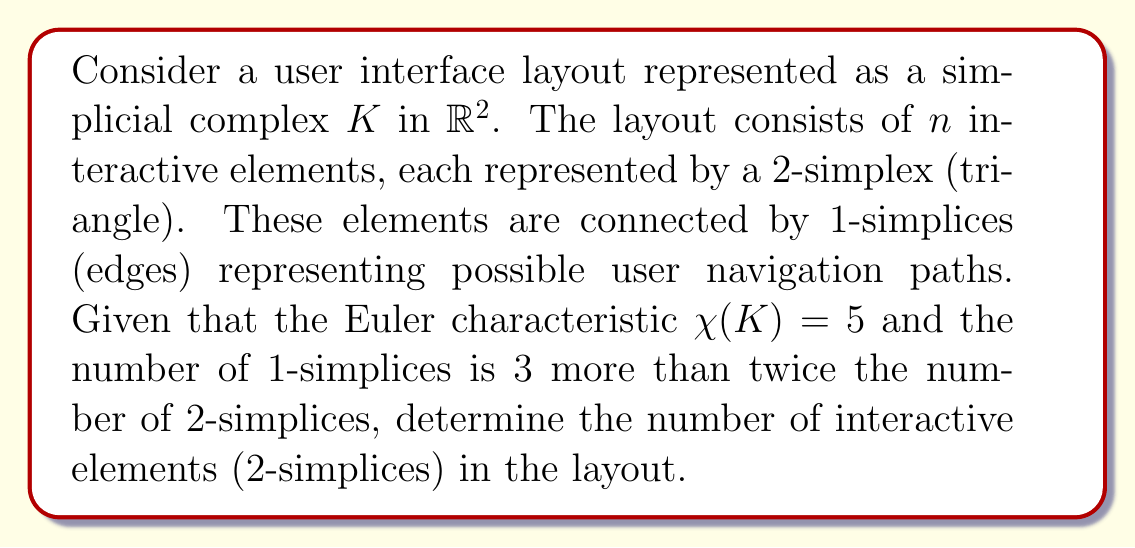Can you answer this question? Let's approach this step-by-step:

1) Let $f_i$ denote the number of $i$-simplices in the complex $K$. We need to find $f_2$, the number of 2-simplices (interactive elements).

2) The Euler characteristic formula for a 2-dimensional simplicial complex is:

   $$\chi(K) = f_0 - f_1 + f_2$$

   where $f_0$ is the number of vertices, $f_1$ is the number of edges, and $f_2$ is the number of triangles.

3) We're given that $\chi(K) = 5$, so:

   $$5 = f_0 - f_1 + f_2$$

4) We're also told that the number of 1-simplices is 3 more than twice the number of 2-simplices:

   $$f_1 = 2f_2 + 3$$

5) In a 2-dimensional simplicial complex, each 2-simplex (triangle) has 3 vertices. Each additional triangle adds at most one new vertex. Therefore, for $n$ triangles:

   $$f_0 \leq n + 2$$

   In our case, $f_0 \leq f_2 + 2$

6) Substituting these into the Euler characteristic equation:

   $$5 = (f_2 + 2) - (2f_2 + 3) + f_2$$

7) Simplifying:

   $$5 = f_2 + 2 - 2f_2 - 3 + f_2$$
   $$5 = 2 - 3 = -1$$

8) Therefore:

   $$f_2 = 6$$
Answer: The number of interactive elements (2-simplices) in the layout is 6. 